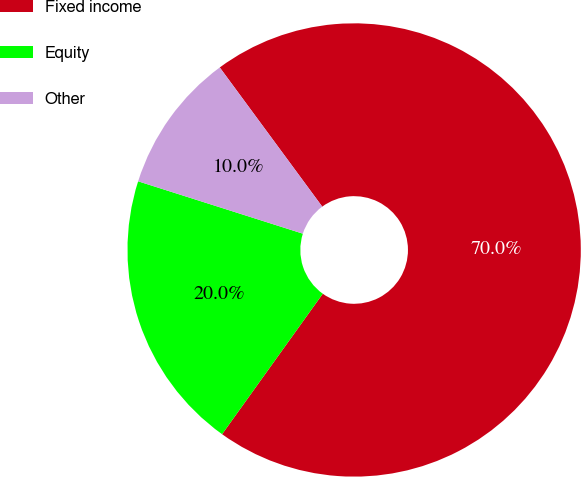Convert chart to OTSL. <chart><loc_0><loc_0><loc_500><loc_500><pie_chart><fcel>Fixed income<fcel>Equity<fcel>Other<nl><fcel>70.0%<fcel>20.0%<fcel>10.0%<nl></chart> 